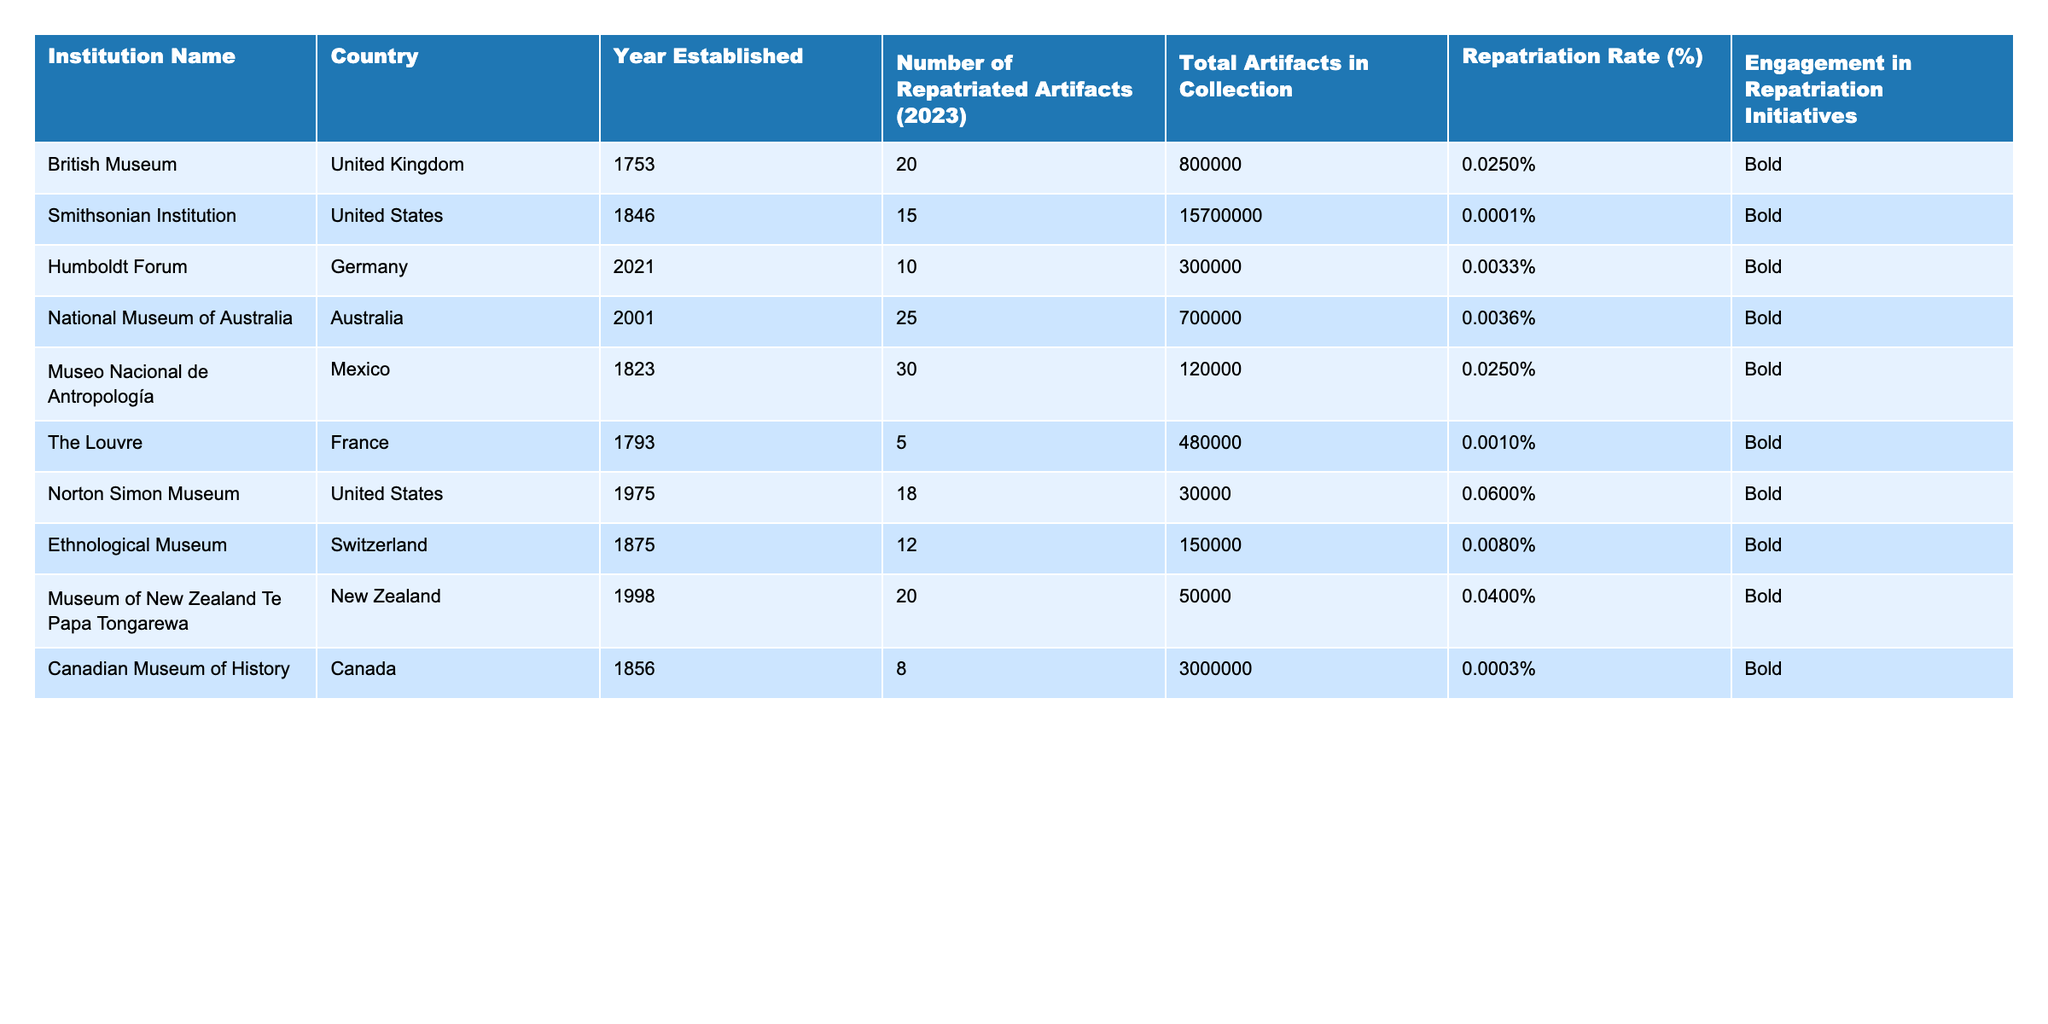What is the total number of repatriated artifacts across all institutions listed? By summing the number of repatriated artifacts for each institution: 20 + 15 + 10 + 25 + 30 + 5 + 18 + 12 + 20 + 8 =  173.
Answer: 173 Which institution has the highest repatriation rate? By looking at the "Repatriation Rate (%)" column, Norton Simon Museum has the highest rate at 0.06%.
Answer: Norton Simon Museum Is the Louvre engaging in repatriation initiatives? According to the table, the Louvre is marked as "Bold" under engagement in repatriation initiatives, indicating it is involved.
Answer: Yes What is the average number of artifacts repatriated per institution? Summing the total repatriated artifacts gives 173, and dividing by the number of institutions (10) gives 173/10 = 17.3.
Answer: 17.3 Which country has the institution with the least number of repatriated artifacts? By checking the "Number of Repatriated Artifacts (2023)", the Louvre has only 5 repatriated artifacts, which is the least among all.
Answer: France (The Louvre) What percentage of the total artifacts in the collection does the National Museum of Australia have in terms of repatriation? The repatriation rate for the National Museum of Australia is 0.0036%, meaning that 0.0036% of 700,000 artifacts (about 25) has been repatriated. Confirmed by its repatriation of 25 artifacts out of 700,000.
Answer: 0.0036% Is there a correlation between the year established and the number of repatriated artifacts for these institutions? There isn't a clear pattern since different institutions with various establishment years have diverse numbers of repatriated artifacts, indicating no direct correlation.
Answer: No What is the total number of artifacts for institutions engaged in repatriation initiatives? Adding the total artifacts for all institutions marked as "Bold" gives: 800,000 (British Museum) + 15,700,000 (Smithsonian Institution) + 300,000 (Humboldt Forum) + 700,000 (National Museum of Australia) + 120,000 (Museo Nacional de Antropología) + 480,000 (The Louvre) + 30,000 (Norton Simon Museum) + 150,000 (Ethnological Museum) + 50,000 (Museum of New Zealand Te Papa Tongarewa) + 3,000,000 (Canadian Museum of History) = 17,716,000.
Answer: 17,716,000 Which institution has the lowest number of artifacts in its collection? From the table, the Norton Simon Museum has the lowest total artifacts in its collection at 30,000.
Answer: Norton Simon Museum How many institutions have a repatriation rate below 0.01%? By reviewing the table, the British Museum (0.025%), Smithsonian Institution (0.0001%), Humboldt Forum (0.0033%), The Louvre (0.001%), and the Canadian Museum of History (0.0003%) all have less than 0.01%, totaling 5 institutions.
Answer: 5 What is the combined total of repatriated artifacts from institutions in the United States? Checking the U.S. institutions, the Smithsonian Institution (15) and Norton Simon Museum (18) gives a total of 15 + 18 = 33 repatriated artifacts combined.
Answer: 33 